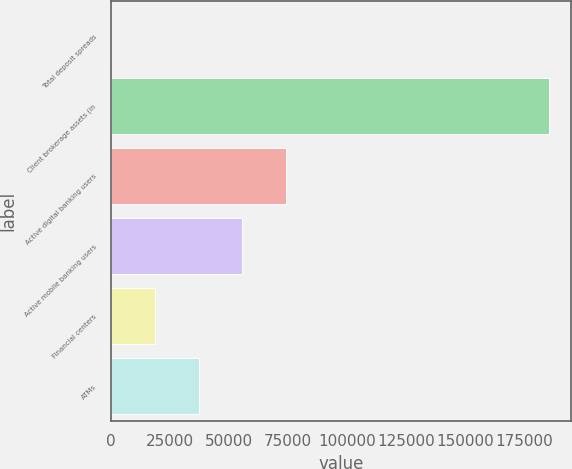Convert chart. <chart><loc_0><loc_0><loc_500><loc_500><bar_chart><fcel>Total deposit spreads<fcel>Client brokerage assets (in<fcel>Active digital banking users<fcel>Active mobile banking users<fcel>Financial centers<fcel>ATMs<nl><fcel>2.14<fcel>185881<fcel>74353.7<fcel>55765.8<fcel>18590<fcel>37177.9<nl></chart> 